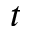Convert formula to latex. <formula><loc_0><loc_0><loc_500><loc_500>t</formula> 